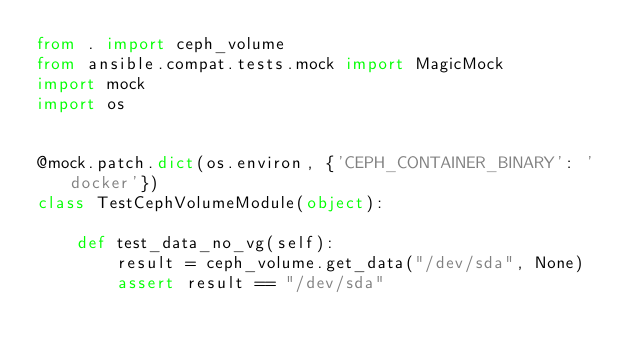Convert code to text. <code><loc_0><loc_0><loc_500><loc_500><_Python_>from . import ceph_volume
from ansible.compat.tests.mock import MagicMock
import mock
import os


@mock.patch.dict(os.environ, {'CEPH_CONTAINER_BINARY': 'docker'})
class TestCephVolumeModule(object):

    def test_data_no_vg(self):
        result = ceph_volume.get_data("/dev/sda", None)
        assert result == "/dev/sda"
</code> 